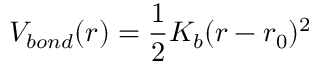Convert formula to latex. <formula><loc_0><loc_0><loc_500><loc_500>V _ { b o n d } ( r ) = \frac { 1 } { 2 } K _ { b } ( r - r _ { 0 } ) ^ { 2 }</formula> 